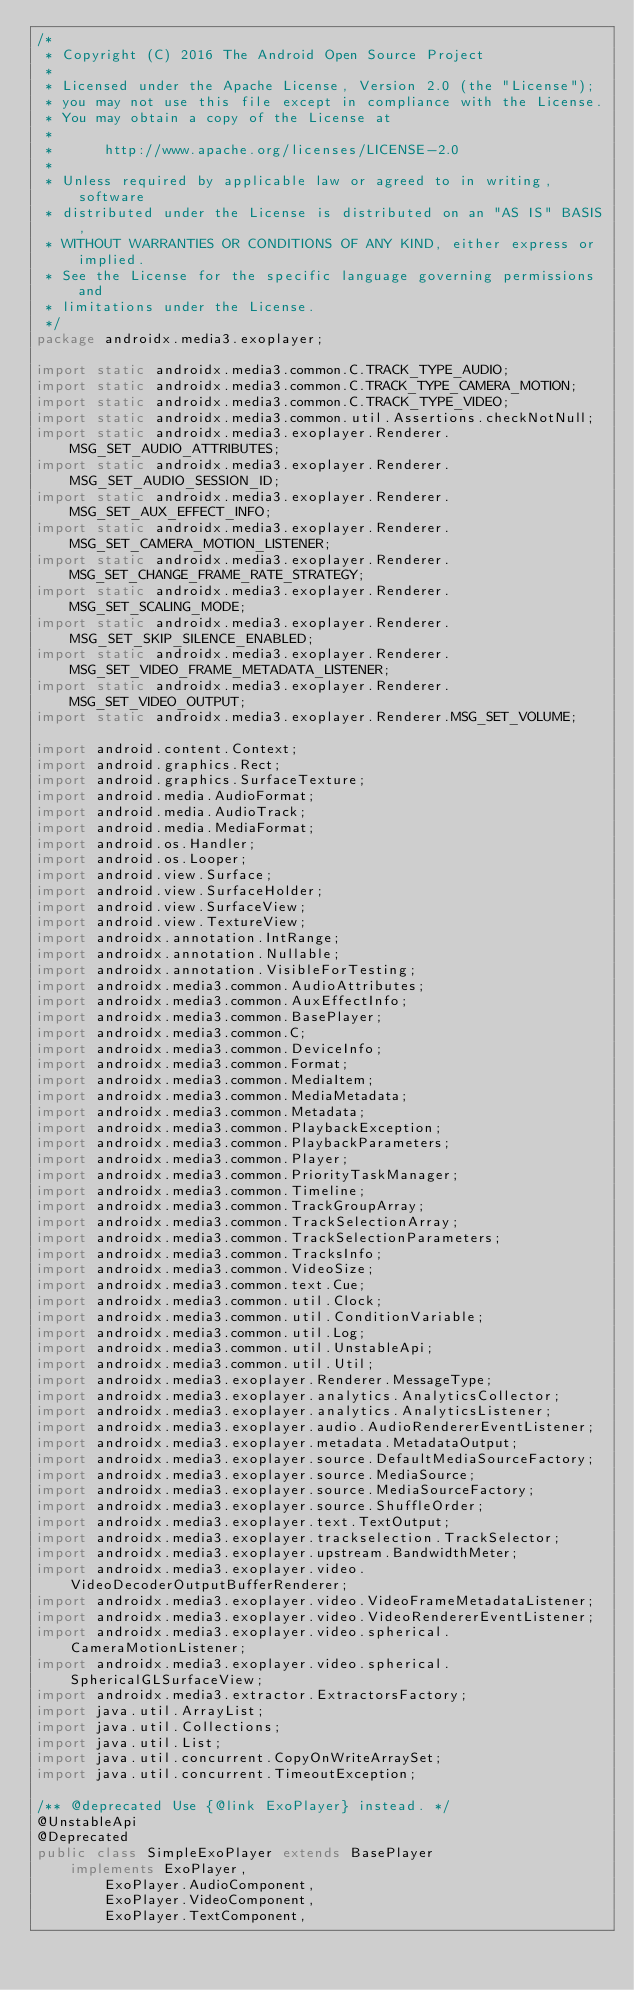Convert code to text. <code><loc_0><loc_0><loc_500><loc_500><_Java_>/*
 * Copyright (C) 2016 The Android Open Source Project
 *
 * Licensed under the Apache License, Version 2.0 (the "License");
 * you may not use this file except in compliance with the License.
 * You may obtain a copy of the License at
 *
 *      http://www.apache.org/licenses/LICENSE-2.0
 *
 * Unless required by applicable law or agreed to in writing, software
 * distributed under the License is distributed on an "AS IS" BASIS,
 * WITHOUT WARRANTIES OR CONDITIONS OF ANY KIND, either express or implied.
 * See the License for the specific language governing permissions and
 * limitations under the License.
 */
package androidx.media3.exoplayer;

import static androidx.media3.common.C.TRACK_TYPE_AUDIO;
import static androidx.media3.common.C.TRACK_TYPE_CAMERA_MOTION;
import static androidx.media3.common.C.TRACK_TYPE_VIDEO;
import static androidx.media3.common.util.Assertions.checkNotNull;
import static androidx.media3.exoplayer.Renderer.MSG_SET_AUDIO_ATTRIBUTES;
import static androidx.media3.exoplayer.Renderer.MSG_SET_AUDIO_SESSION_ID;
import static androidx.media3.exoplayer.Renderer.MSG_SET_AUX_EFFECT_INFO;
import static androidx.media3.exoplayer.Renderer.MSG_SET_CAMERA_MOTION_LISTENER;
import static androidx.media3.exoplayer.Renderer.MSG_SET_CHANGE_FRAME_RATE_STRATEGY;
import static androidx.media3.exoplayer.Renderer.MSG_SET_SCALING_MODE;
import static androidx.media3.exoplayer.Renderer.MSG_SET_SKIP_SILENCE_ENABLED;
import static androidx.media3.exoplayer.Renderer.MSG_SET_VIDEO_FRAME_METADATA_LISTENER;
import static androidx.media3.exoplayer.Renderer.MSG_SET_VIDEO_OUTPUT;
import static androidx.media3.exoplayer.Renderer.MSG_SET_VOLUME;

import android.content.Context;
import android.graphics.Rect;
import android.graphics.SurfaceTexture;
import android.media.AudioFormat;
import android.media.AudioTrack;
import android.media.MediaFormat;
import android.os.Handler;
import android.os.Looper;
import android.view.Surface;
import android.view.SurfaceHolder;
import android.view.SurfaceView;
import android.view.TextureView;
import androidx.annotation.IntRange;
import androidx.annotation.Nullable;
import androidx.annotation.VisibleForTesting;
import androidx.media3.common.AudioAttributes;
import androidx.media3.common.AuxEffectInfo;
import androidx.media3.common.BasePlayer;
import androidx.media3.common.C;
import androidx.media3.common.DeviceInfo;
import androidx.media3.common.Format;
import androidx.media3.common.MediaItem;
import androidx.media3.common.MediaMetadata;
import androidx.media3.common.Metadata;
import androidx.media3.common.PlaybackException;
import androidx.media3.common.PlaybackParameters;
import androidx.media3.common.Player;
import androidx.media3.common.PriorityTaskManager;
import androidx.media3.common.Timeline;
import androidx.media3.common.TrackGroupArray;
import androidx.media3.common.TrackSelectionArray;
import androidx.media3.common.TrackSelectionParameters;
import androidx.media3.common.TracksInfo;
import androidx.media3.common.VideoSize;
import androidx.media3.common.text.Cue;
import androidx.media3.common.util.Clock;
import androidx.media3.common.util.ConditionVariable;
import androidx.media3.common.util.Log;
import androidx.media3.common.util.UnstableApi;
import androidx.media3.common.util.Util;
import androidx.media3.exoplayer.Renderer.MessageType;
import androidx.media3.exoplayer.analytics.AnalyticsCollector;
import androidx.media3.exoplayer.analytics.AnalyticsListener;
import androidx.media3.exoplayer.audio.AudioRendererEventListener;
import androidx.media3.exoplayer.metadata.MetadataOutput;
import androidx.media3.exoplayer.source.DefaultMediaSourceFactory;
import androidx.media3.exoplayer.source.MediaSource;
import androidx.media3.exoplayer.source.MediaSourceFactory;
import androidx.media3.exoplayer.source.ShuffleOrder;
import androidx.media3.exoplayer.text.TextOutput;
import androidx.media3.exoplayer.trackselection.TrackSelector;
import androidx.media3.exoplayer.upstream.BandwidthMeter;
import androidx.media3.exoplayer.video.VideoDecoderOutputBufferRenderer;
import androidx.media3.exoplayer.video.VideoFrameMetadataListener;
import androidx.media3.exoplayer.video.VideoRendererEventListener;
import androidx.media3.exoplayer.video.spherical.CameraMotionListener;
import androidx.media3.exoplayer.video.spherical.SphericalGLSurfaceView;
import androidx.media3.extractor.ExtractorsFactory;
import java.util.ArrayList;
import java.util.Collections;
import java.util.List;
import java.util.concurrent.CopyOnWriteArraySet;
import java.util.concurrent.TimeoutException;

/** @deprecated Use {@link ExoPlayer} instead. */
@UnstableApi
@Deprecated
public class SimpleExoPlayer extends BasePlayer
    implements ExoPlayer,
        ExoPlayer.AudioComponent,
        ExoPlayer.VideoComponent,
        ExoPlayer.TextComponent,</code> 